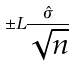<formula> <loc_0><loc_0><loc_500><loc_500>\pm L \frac { \hat { \sigma } } { \sqrt { n } }</formula> 